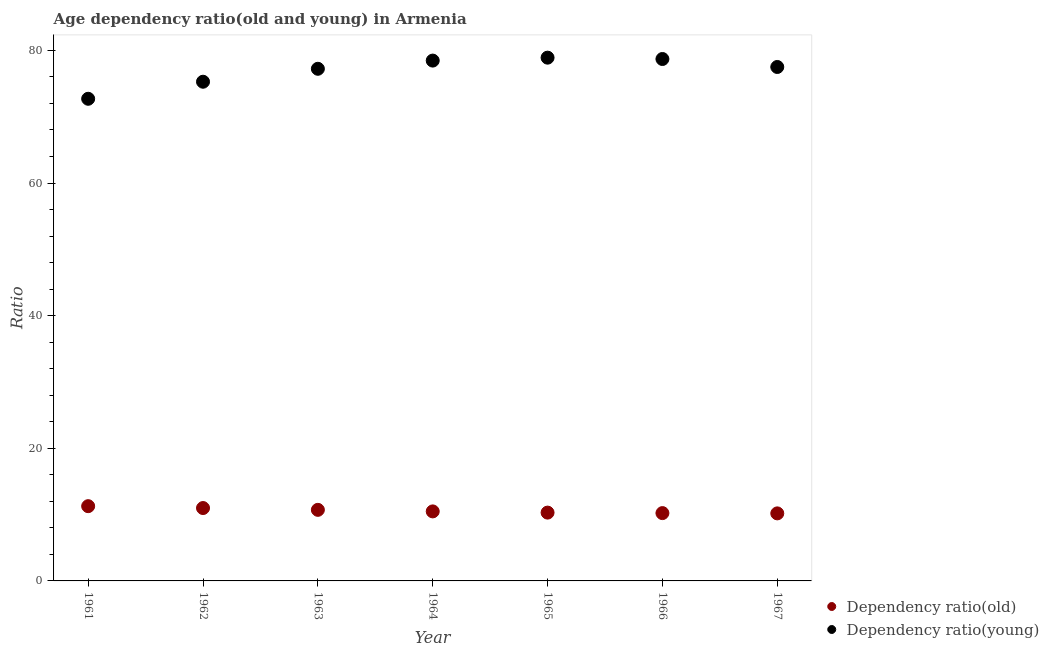How many different coloured dotlines are there?
Keep it short and to the point. 2. What is the age dependency ratio(young) in 1967?
Give a very brief answer. 77.5. Across all years, what is the maximum age dependency ratio(young)?
Provide a succinct answer. 78.9. Across all years, what is the minimum age dependency ratio(young)?
Offer a very short reply. 72.7. In which year was the age dependency ratio(young) maximum?
Provide a short and direct response. 1965. In which year was the age dependency ratio(young) minimum?
Provide a short and direct response. 1961. What is the total age dependency ratio(old) in the graph?
Your response must be concise. 74.17. What is the difference between the age dependency ratio(young) in 1962 and that in 1963?
Ensure brevity in your answer.  -1.95. What is the difference between the age dependency ratio(old) in 1962 and the age dependency ratio(young) in 1967?
Provide a succinct answer. -66.51. What is the average age dependency ratio(old) per year?
Provide a short and direct response. 10.6. In the year 1964, what is the difference between the age dependency ratio(young) and age dependency ratio(old)?
Give a very brief answer. 67.98. What is the ratio of the age dependency ratio(old) in 1962 to that in 1965?
Offer a terse response. 1.07. What is the difference between the highest and the second highest age dependency ratio(young)?
Your answer should be compact. 0.2. What is the difference between the highest and the lowest age dependency ratio(old)?
Provide a succinct answer. 1.09. In how many years, is the age dependency ratio(young) greater than the average age dependency ratio(young) taken over all years?
Provide a short and direct response. 5. Is the age dependency ratio(young) strictly greater than the age dependency ratio(old) over the years?
Your answer should be compact. Yes. How many dotlines are there?
Provide a succinct answer. 2. Are the values on the major ticks of Y-axis written in scientific E-notation?
Offer a very short reply. No. Does the graph contain any zero values?
Your answer should be compact. No. Does the graph contain grids?
Offer a terse response. No. Where does the legend appear in the graph?
Your answer should be compact. Bottom right. How are the legend labels stacked?
Your answer should be compact. Vertical. What is the title of the graph?
Offer a very short reply. Age dependency ratio(old and young) in Armenia. Does "Private credit bureau" appear as one of the legend labels in the graph?
Offer a terse response. No. What is the label or title of the X-axis?
Provide a succinct answer. Year. What is the label or title of the Y-axis?
Offer a terse response. Ratio. What is the Ratio in Dependency ratio(old) in 1961?
Ensure brevity in your answer.  11.27. What is the Ratio in Dependency ratio(young) in 1961?
Give a very brief answer. 72.7. What is the Ratio of Dependency ratio(old) in 1962?
Your answer should be very brief. 10.99. What is the Ratio of Dependency ratio(young) in 1962?
Keep it short and to the point. 75.27. What is the Ratio in Dependency ratio(old) in 1963?
Your response must be concise. 10.72. What is the Ratio in Dependency ratio(young) in 1963?
Your response must be concise. 77.22. What is the Ratio in Dependency ratio(old) in 1964?
Make the answer very short. 10.48. What is the Ratio of Dependency ratio(young) in 1964?
Provide a short and direct response. 78.46. What is the Ratio in Dependency ratio(old) in 1965?
Ensure brevity in your answer.  10.3. What is the Ratio of Dependency ratio(young) in 1965?
Keep it short and to the point. 78.9. What is the Ratio in Dependency ratio(old) in 1966?
Provide a succinct answer. 10.23. What is the Ratio in Dependency ratio(young) in 1966?
Provide a short and direct response. 78.7. What is the Ratio of Dependency ratio(old) in 1967?
Offer a very short reply. 10.18. What is the Ratio in Dependency ratio(young) in 1967?
Provide a short and direct response. 77.5. Across all years, what is the maximum Ratio of Dependency ratio(old)?
Keep it short and to the point. 11.27. Across all years, what is the maximum Ratio in Dependency ratio(young)?
Provide a short and direct response. 78.9. Across all years, what is the minimum Ratio of Dependency ratio(old)?
Offer a terse response. 10.18. Across all years, what is the minimum Ratio in Dependency ratio(young)?
Your response must be concise. 72.7. What is the total Ratio of Dependency ratio(old) in the graph?
Your answer should be compact. 74.17. What is the total Ratio in Dependency ratio(young) in the graph?
Offer a terse response. 538.75. What is the difference between the Ratio of Dependency ratio(old) in 1961 and that in 1962?
Your response must be concise. 0.28. What is the difference between the Ratio in Dependency ratio(young) in 1961 and that in 1962?
Offer a very short reply. -2.57. What is the difference between the Ratio in Dependency ratio(old) in 1961 and that in 1963?
Your response must be concise. 0.55. What is the difference between the Ratio of Dependency ratio(young) in 1961 and that in 1963?
Offer a very short reply. -4.52. What is the difference between the Ratio in Dependency ratio(old) in 1961 and that in 1964?
Provide a short and direct response. 0.79. What is the difference between the Ratio of Dependency ratio(young) in 1961 and that in 1964?
Your answer should be very brief. -5.76. What is the difference between the Ratio of Dependency ratio(old) in 1961 and that in 1965?
Give a very brief answer. 0.97. What is the difference between the Ratio of Dependency ratio(young) in 1961 and that in 1965?
Your response must be concise. -6.2. What is the difference between the Ratio in Dependency ratio(old) in 1961 and that in 1966?
Offer a terse response. 1.05. What is the difference between the Ratio in Dependency ratio(young) in 1961 and that in 1966?
Your answer should be very brief. -6. What is the difference between the Ratio of Dependency ratio(old) in 1961 and that in 1967?
Offer a very short reply. 1.09. What is the difference between the Ratio in Dependency ratio(young) in 1961 and that in 1967?
Provide a succinct answer. -4.8. What is the difference between the Ratio in Dependency ratio(old) in 1962 and that in 1963?
Offer a terse response. 0.27. What is the difference between the Ratio of Dependency ratio(young) in 1962 and that in 1963?
Offer a terse response. -1.95. What is the difference between the Ratio of Dependency ratio(old) in 1962 and that in 1964?
Provide a succinct answer. 0.51. What is the difference between the Ratio of Dependency ratio(young) in 1962 and that in 1964?
Keep it short and to the point. -3.19. What is the difference between the Ratio of Dependency ratio(old) in 1962 and that in 1965?
Your response must be concise. 0.69. What is the difference between the Ratio of Dependency ratio(young) in 1962 and that in 1965?
Your response must be concise. -3.63. What is the difference between the Ratio of Dependency ratio(old) in 1962 and that in 1966?
Offer a terse response. 0.76. What is the difference between the Ratio of Dependency ratio(young) in 1962 and that in 1966?
Keep it short and to the point. -3.43. What is the difference between the Ratio of Dependency ratio(old) in 1962 and that in 1967?
Keep it short and to the point. 0.81. What is the difference between the Ratio of Dependency ratio(young) in 1962 and that in 1967?
Keep it short and to the point. -2.22. What is the difference between the Ratio in Dependency ratio(old) in 1963 and that in 1964?
Your response must be concise. 0.23. What is the difference between the Ratio in Dependency ratio(young) in 1963 and that in 1964?
Your answer should be very brief. -1.24. What is the difference between the Ratio in Dependency ratio(old) in 1963 and that in 1965?
Provide a short and direct response. 0.42. What is the difference between the Ratio of Dependency ratio(young) in 1963 and that in 1965?
Make the answer very short. -1.68. What is the difference between the Ratio of Dependency ratio(old) in 1963 and that in 1966?
Your answer should be compact. 0.49. What is the difference between the Ratio in Dependency ratio(young) in 1963 and that in 1966?
Keep it short and to the point. -1.48. What is the difference between the Ratio of Dependency ratio(old) in 1963 and that in 1967?
Offer a very short reply. 0.53. What is the difference between the Ratio of Dependency ratio(young) in 1963 and that in 1967?
Make the answer very short. -0.27. What is the difference between the Ratio in Dependency ratio(old) in 1964 and that in 1965?
Give a very brief answer. 0.18. What is the difference between the Ratio in Dependency ratio(young) in 1964 and that in 1965?
Give a very brief answer. -0.44. What is the difference between the Ratio of Dependency ratio(old) in 1964 and that in 1966?
Make the answer very short. 0.26. What is the difference between the Ratio in Dependency ratio(young) in 1964 and that in 1966?
Offer a very short reply. -0.24. What is the difference between the Ratio of Dependency ratio(old) in 1964 and that in 1967?
Make the answer very short. 0.3. What is the difference between the Ratio in Dependency ratio(young) in 1964 and that in 1967?
Offer a terse response. 0.96. What is the difference between the Ratio of Dependency ratio(old) in 1965 and that in 1966?
Provide a short and direct response. 0.07. What is the difference between the Ratio of Dependency ratio(young) in 1965 and that in 1966?
Offer a terse response. 0.2. What is the difference between the Ratio in Dependency ratio(old) in 1965 and that in 1967?
Give a very brief answer. 0.12. What is the difference between the Ratio in Dependency ratio(young) in 1965 and that in 1967?
Give a very brief answer. 1.41. What is the difference between the Ratio of Dependency ratio(old) in 1966 and that in 1967?
Ensure brevity in your answer.  0.04. What is the difference between the Ratio of Dependency ratio(young) in 1966 and that in 1967?
Offer a very short reply. 1.2. What is the difference between the Ratio in Dependency ratio(old) in 1961 and the Ratio in Dependency ratio(young) in 1962?
Your answer should be compact. -64. What is the difference between the Ratio in Dependency ratio(old) in 1961 and the Ratio in Dependency ratio(young) in 1963?
Your answer should be compact. -65.95. What is the difference between the Ratio in Dependency ratio(old) in 1961 and the Ratio in Dependency ratio(young) in 1964?
Provide a short and direct response. -67.19. What is the difference between the Ratio of Dependency ratio(old) in 1961 and the Ratio of Dependency ratio(young) in 1965?
Give a very brief answer. -67.63. What is the difference between the Ratio in Dependency ratio(old) in 1961 and the Ratio in Dependency ratio(young) in 1966?
Offer a terse response. -67.43. What is the difference between the Ratio of Dependency ratio(old) in 1961 and the Ratio of Dependency ratio(young) in 1967?
Offer a very short reply. -66.22. What is the difference between the Ratio of Dependency ratio(old) in 1962 and the Ratio of Dependency ratio(young) in 1963?
Give a very brief answer. -66.23. What is the difference between the Ratio in Dependency ratio(old) in 1962 and the Ratio in Dependency ratio(young) in 1964?
Offer a terse response. -67.47. What is the difference between the Ratio in Dependency ratio(old) in 1962 and the Ratio in Dependency ratio(young) in 1965?
Provide a short and direct response. -67.91. What is the difference between the Ratio in Dependency ratio(old) in 1962 and the Ratio in Dependency ratio(young) in 1966?
Offer a terse response. -67.71. What is the difference between the Ratio of Dependency ratio(old) in 1962 and the Ratio of Dependency ratio(young) in 1967?
Your answer should be very brief. -66.51. What is the difference between the Ratio of Dependency ratio(old) in 1963 and the Ratio of Dependency ratio(young) in 1964?
Offer a very short reply. -67.74. What is the difference between the Ratio of Dependency ratio(old) in 1963 and the Ratio of Dependency ratio(young) in 1965?
Your response must be concise. -68.18. What is the difference between the Ratio in Dependency ratio(old) in 1963 and the Ratio in Dependency ratio(young) in 1966?
Provide a succinct answer. -67.98. What is the difference between the Ratio of Dependency ratio(old) in 1963 and the Ratio of Dependency ratio(young) in 1967?
Offer a very short reply. -66.78. What is the difference between the Ratio of Dependency ratio(old) in 1964 and the Ratio of Dependency ratio(young) in 1965?
Ensure brevity in your answer.  -68.42. What is the difference between the Ratio of Dependency ratio(old) in 1964 and the Ratio of Dependency ratio(young) in 1966?
Provide a succinct answer. -68.22. What is the difference between the Ratio in Dependency ratio(old) in 1964 and the Ratio in Dependency ratio(young) in 1967?
Ensure brevity in your answer.  -67.01. What is the difference between the Ratio of Dependency ratio(old) in 1965 and the Ratio of Dependency ratio(young) in 1966?
Provide a succinct answer. -68.4. What is the difference between the Ratio in Dependency ratio(old) in 1965 and the Ratio in Dependency ratio(young) in 1967?
Your answer should be compact. -67.2. What is the difference between the Ratio of Dependency ratio(old) in 1966 and the Ratio of Dependency ratio(young) in 1967?
Keep it short and to the point. -67.27. What is the average Ratio in Dependency ratio(old) per year?
Make the answer very short. 10.6. What is the average Ratio of Dependency ratio(young) per year?
Your answer should be very brief. 76.97. In the year 1961, what is the difference between the Ratio of Dependency ratio(old) and Ratio of Dependency ratio(young)?
Your response must be concise. -61.43. In the year 1962, what is the difference between the Ratio of Dependency ratio(old) and Ratio of Dependency ratio(young)?
Your answer should be compact. -64.28. In the year 1963, what is the difference between the Ratio of Dependency ratio(old) and Ratio of Dependency ratio(young)?
Offer a very short reply. -66.51. In the year 1964, what is the difference between the Ratio of Dependency ratio(old) and Ratio of Dependency ratio(young)?
Your response must be concise. -67.98. In the year 1965, what is the difference between the Ratio in Dependency ratio(old) and Ratio in Dependency ratio(young)?
Make the answer very short. -68.6. In the year 1966, what is the difference between the Ratio of Dependency ratio(old) and Ratio of Dependency ratio(young)?
Provide a succinct answer. -68.47. In the year 1967, what is the difference between the Ratio of Dependency ratio(old) and Ratio of Dependency ratio(young)?
Provide a succinct answer. -67.31. What is the ratio of the Ratio of Dependency ratio(old) in 1961 to that in 1962?
Offer a terse response. 1.03. What is the ratio of the Ratio of Dependency ratio(young) in 1961 to that in 1962?
Your answer should be compact. 0.97. What is the ratio of the Ratio in Dependency ratio(old) in 1961 to that in 1963?
Ensure brevity in your answer.  1.05. What is the ratio of the Ratio in Dependency ratio(young) in 1961 to that in 1963?
Ensure brevity in your answer.  0.94. What is the ratio of the Ratio in Dependency ratio(old) in 1961 to that in 1964?
Offer a terse response. 1.08. What is the ratio of the Ratio in Dependency ratio(young) in 1961 to that in 1964?
Your answer should be compact. 0.93. What is the ratio of the Ratio in Dependency ratio(old) in 1961 to that in 1965?
Your response must be concise. 1.09. What is the ratio of the Ratio of Dependency ratio(young) in 1961 to that in 1965?
Keep it short and to the point. 0.92. What is the ratio of the Ratio of Dependency ratio(old) in 1961 to that in 1966?
Your response must be concise. 1.1. What is the ratio of the Ratio in Dependency ratio(young) in 1961 to that in 1966?
Your answer should be compact. 0.92. What is the ratio of the Ratio of Dependency ratio(old) in 1961 to that in 1967?
Ensure brevity in your answer.  1.11. What is the ratio of the Ratio in Dependency ratio(young) in 1961 to that in 1967?
Offer a terse response. 0.94. What is the ratio of the Ratio in Dependency ratio(old) in 1962 to that in 1963?
Provide a succinct answer. 1.03. What is the ratio of the Ratio in Dependency ratio(young) in 1962 to that in 1963?
Give a very brief answer. 0.97. What is the ratio of the Ratio in Dependency ratio(old) in 1962 to that in 1964?
Offer a very short reply. 1.05. What is the ratio of the Ratio of Dependency ratio(young) in 1962 to that in 1964?
Offer a terse response. 0.96. What is the ratio of the Ratio of Dependency ratio(old) in 1962 to that in 1965?
Your response must be concise. 1.07. What is the ratio of the Ratio of Dependency ratio(young) in 1962 to that in 1965?
Your answer should be compact. 0.95. What is the ratio of the Ratio of Dependency ratio(old) in 1962 to that in 1966?
Offer a very short reply. 1.07. What is the ratio of the Ratio of Dependency ratio(young) in 1962 to that in 1966?
Your answer should be very brief. 0.96. What is the ratio of the Ratio of Dependency ratio(old) in 1962 to that in 1967?
Your answer should be very brief. 1.08. What is the ratio of the Ratio of Dependency ratio(young) in 1962 to that in 1967?
Your response must be concise. 0.97. What is the ratio of the Ratio of Dependency ratio(old) in 1963 to that in 1964?
Provide a short and direct response. 1.02. What is the ratio of the Ratio of Dependency ratio(young) in 1963 to that in 1964?
Provide a succinct answer. 0.98. What is the ratio of the Ratio in Dependency ratio(old) in 1963 to that in 1965?
Your answer should be very brief. 1.04. What is the ratio of the Ratio in Dependency ratio(young) in 1963 to that in 1965?
Keep it short and to the point. 0.98. What is the ratio of the Ratio in Dependency ratio(old) in 1963 to that in 1966?
Offer a terse response. 1.05. What is the ratio of the Ratio in Dependency ratio(young) in 1963 to that in 1966?
Your answer should be very brief. 0.98. What is the ratio of the Ratio in Dependency ratio(old) in 1963 to that in 1967?
Your answer should be compact. 1.05. What is the ratio of the Ratio in Dependency ratio(young) in 1963 to that in 1967?
Make the answer very short. 1. What is the ratio of the Ratio in Dependency ratio(old) in 1964 to that in 1965?
Your answer should be very brief. 1.02. What is the ratio of the Ratio in Dependency ratio(young) in 1964 to that in 1965?
Keep it short and to the point. 0.99. What is the ratio of the Ratio in Dependency ratio(old) in 1964 to that in 1966?
Keep it short and to the point. 1.03. What is the ratio of the Ratio in Dependency ratio(young) in 1964 to that in 1966?
Give a very brief answer. 1. What is the ratio of the Ratio of Dependency ratio(old) in 1964 to that in 1967?
Provide a succinct answer. 1.03. What is the ratio of the Ratio of Dependency ratio(young) in 1964 to that in 1967?
Give a very brief answer. 1.01. What is the ratio of the Ratio of Dependency ratio(old) in 1965 to that in 1966?
Your answer should be very brief. 1.01. What is the ratio of the Ratio in Dependency ratio(old) in 1965 to that in 1967?
Keep it short and to the point. 1.01. What is the ratio of the Ratio of Dependency ratio(young) in 1965 to that in 1967?
Give a very brief answer. 1.02. What is the ratio of the Ratio in Dependency ratio(young) in 1966 to that in 1967?
Provide a short and direct response. 1.02. What is the difference between the highest and the second highest Ratio of Dependency ratio(old)?
Offer a terse response. 0.28. What is the difference between the highest and the second highest Ratio of Dependency ratio(young)?
Offer a terse response. 0.2. What is the difference between the highest and the lowest Ratio of Dependency ratio(old)?
Make the answer very short. 1.09. What is the difference between the highest and the lowest Ratio in Dependency ratio(young)?
Your response must be concise. 6.2. 